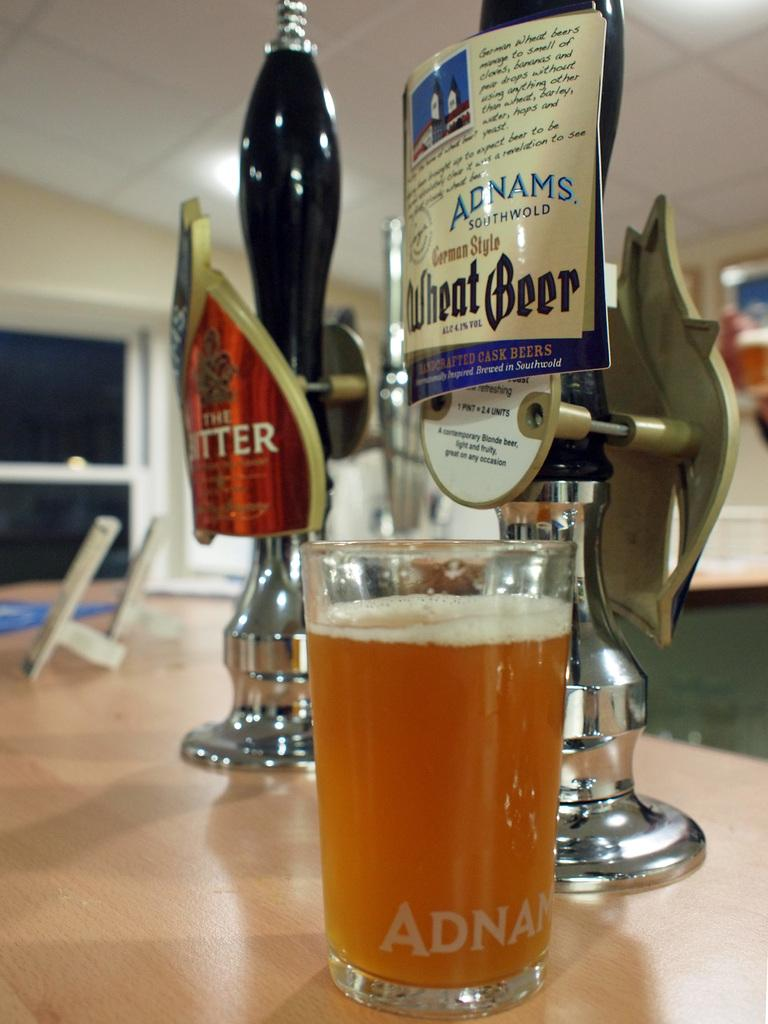<image>
Create a compact narrative representing the image presented. Beer tap with a label that says "Wheat Beer". 